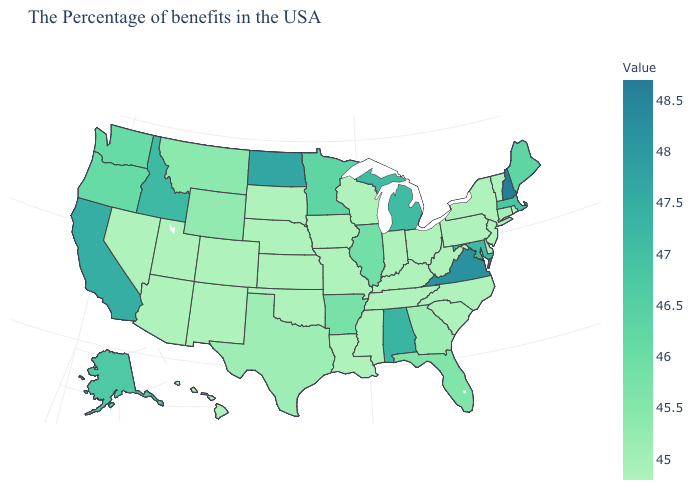Among the states that border Wyoming , does Utah have the lowest value?
Answer briefly. Yes. Which states hav the highest value in the MidWest?
Short answer required. North Dakota. Which states hav the highest value in the West?
Answer briefly. California. Among the states that border Wisconsin , does Michigan have the highest value?
Be succinct. Yes. Among the states that border Michigan , which have the highest value?
Concise answer only. Ohio, Indiana, Wisconsin. Does Nevada have a higher value than Washington?
Short answer required. No. Among the states that border Georgia , does Alabama have the highest value?
Short answer required. Yes. 